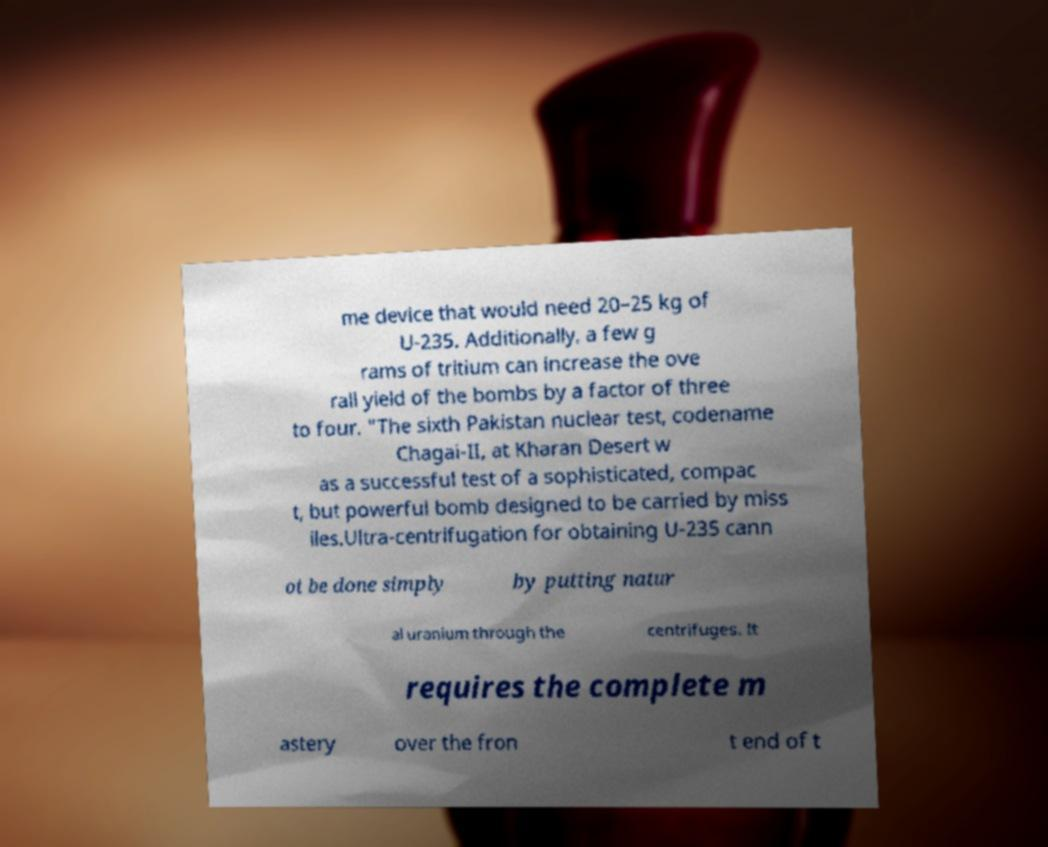There's text embedded in this image that I need extracted. Can you transcribe it verbatim? me device that would need 20–25 kg of U-235. Additionally, a few g rams of tritium can increase the ove rall yield of the bombs by a factor of three to four. "The sixth Pakistan nuclear test, codename Chagai-II, at Kharan Desert w as a successful test of a sophisticated, compac t, but powerful bomb designed to be carried by miss iles.Ultra-centrifugation for obtaining U-235 cann ot be done simply by putting natur al uranium through the centrifuges. It requires the complete m astery over the fron t end of t 